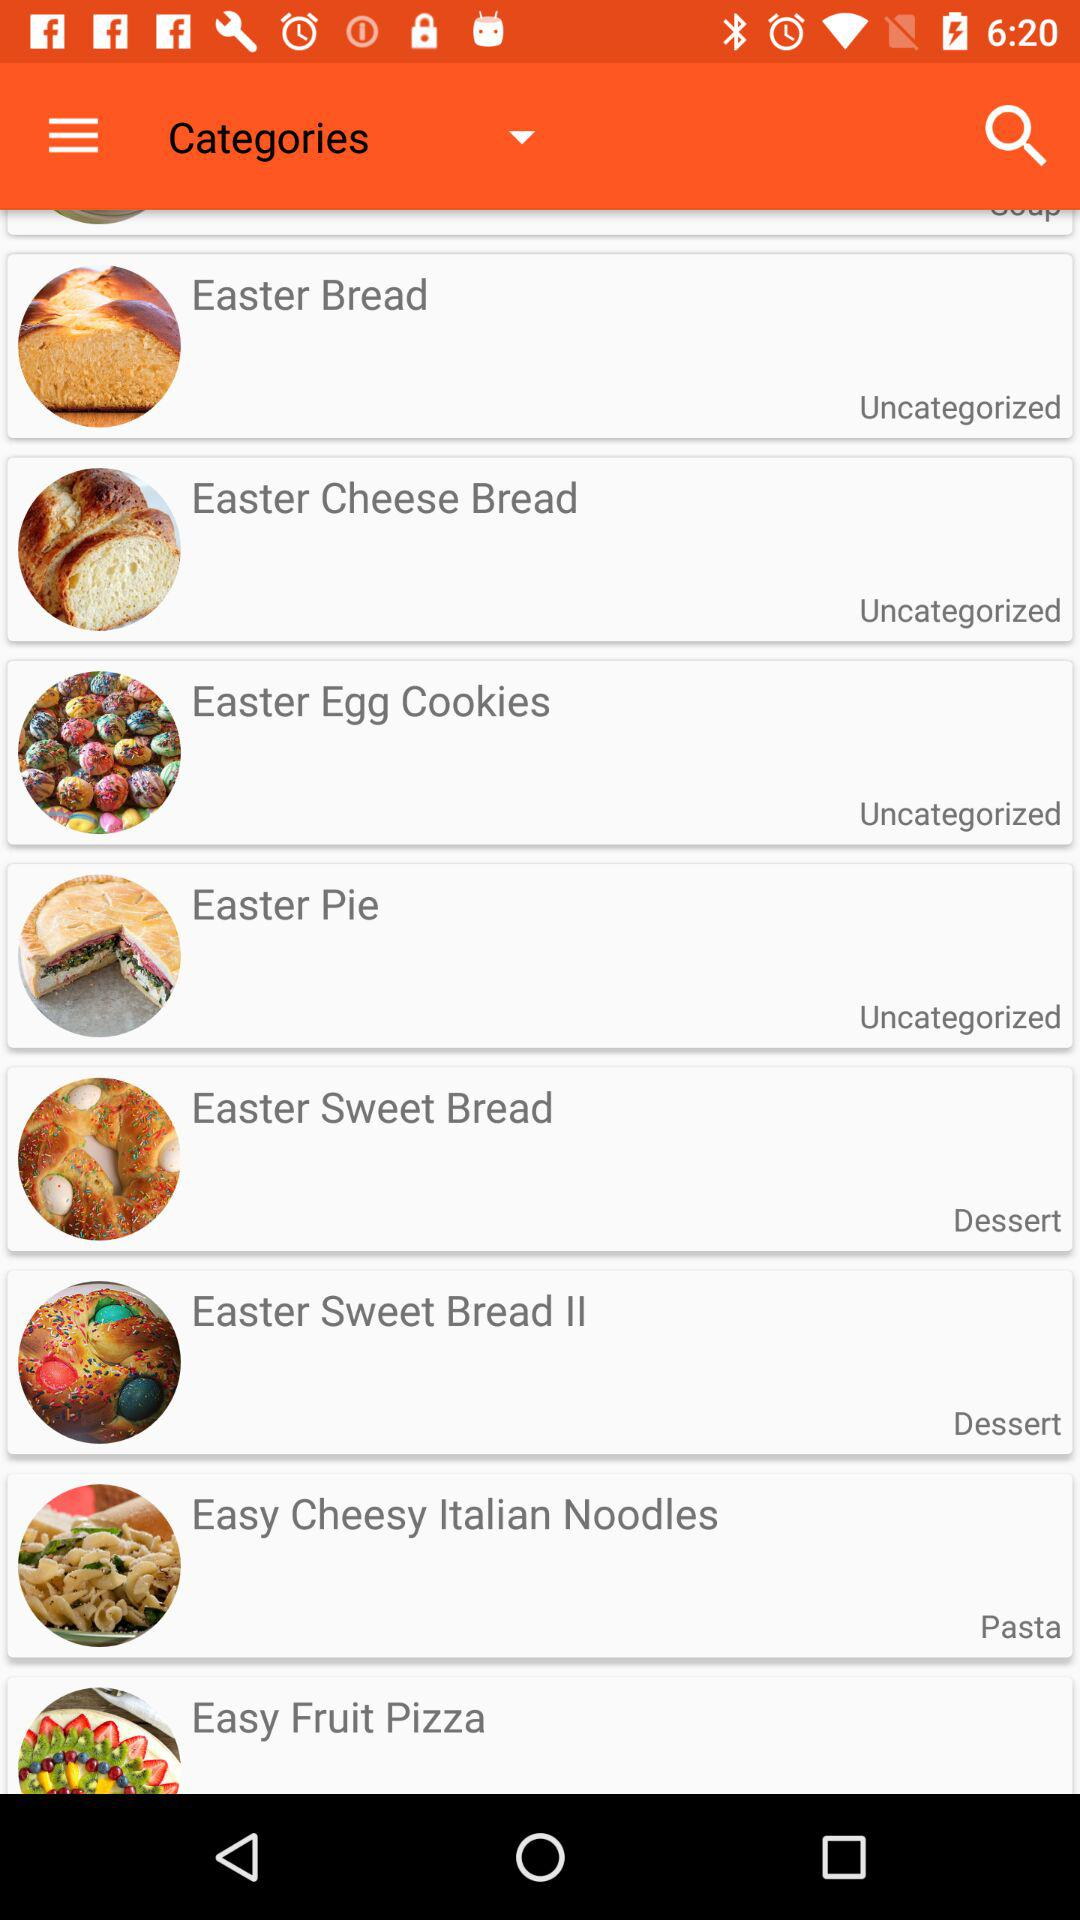What is the category of "Easter Sweet Bread"? The category of "Easter Sweet Bread" is "Dessert". 